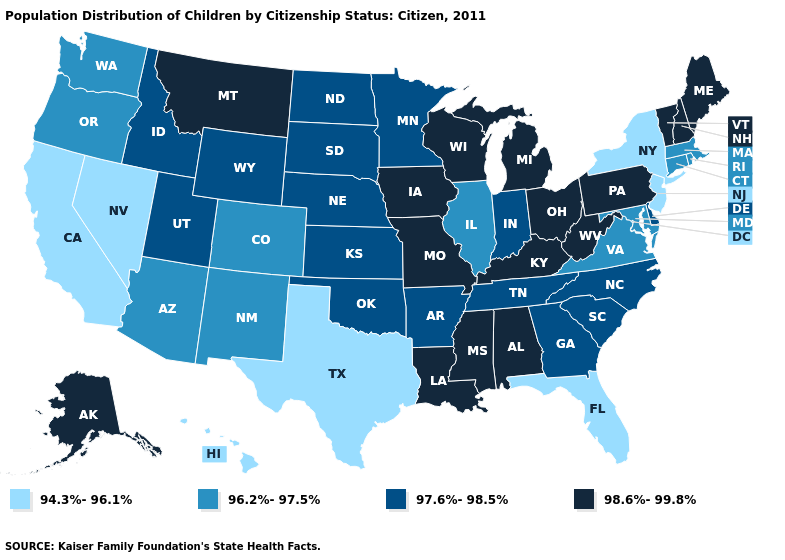Name the states that have a value in the range 98.6%-99.8%?
Answer briefly. Alabama, Alaska, Iowa, Kentucky, Louisiana, Maine, Michigan, Mississippi, Missouri, Montana, New Hampshire, Ohio, Pennsylvania, Vermont, West Virginia, Wisconsin. What is the value of Texas?
Concise answer only. 94.3%-96.1%. Does the first symbol in the legend represent the smallest category?
Keep it brief. Yes. Which states have the highest value in the USA?
Answer briefly. Alabama, Alaska, Iowa, Kentucky, Louisiana, Maine, Michigan, Mississippi, Missouri, Montana, New Hampshire, Ohio, Pennsylvania, Vermont, West Virginia, Wisconsin. Among the states that border Indiana , does Kentucky have the lowest value?
Concise answer only. No. Which states hav the highest value in the South?
Quick response, please. Alabama, Kentucky, Louisiana, Mississippi, West Virginia. Name the states that have a value in the range 96.2%-97.5%?
Give a very brief answer. Arizona, Colorado, Connecticut, Illinois, Maryland, Massachusetts, New Mexico, Oregon, Rhode Island, Virginia, Washington. Does the map have missing data?
Concise answer only. No. What is the value of Montana?
Quick response, please. 98.6%-99.8%. What is the highest value in states that border Mississippi?
Keep it brief. 98.6%-99.8%. Does Montana have the highest value in the West?
Concise answer only. Yes. Does Nebraska have the lowest value in the MidWest?
Quick response, please. No. Name the states that have a value in the range 97.6%-98.5%?
Quick response, please. Arkansas, Delaware, Georgia, Idaho, Indiana, Kansas, Minnesota, Nebraska, North Carolina, North Dakota, Oklahoma, South Carolina, South Dakota, Tennessee, Utah, Wyoming. What is the lowest value in states that border Illinois?
Give a very brief answer. 97.6%-98.5%. Does Maine have the lowest value in the USA?
Answer briefly. No. 